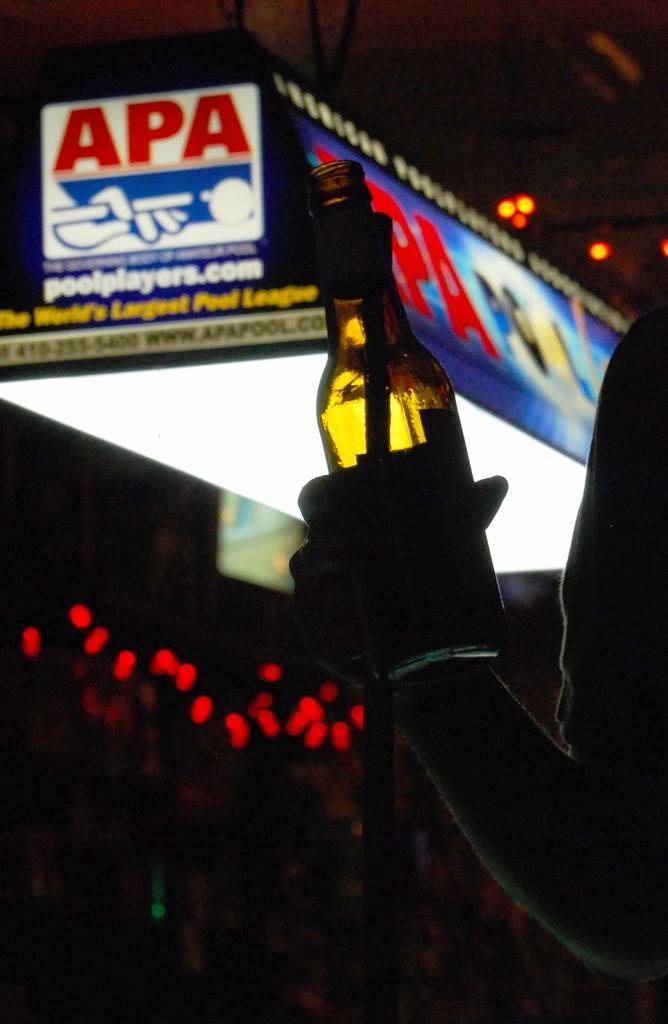<image>
Provide a brief description of the given image. Man holding a bottle in front of a sign that says "APA". 